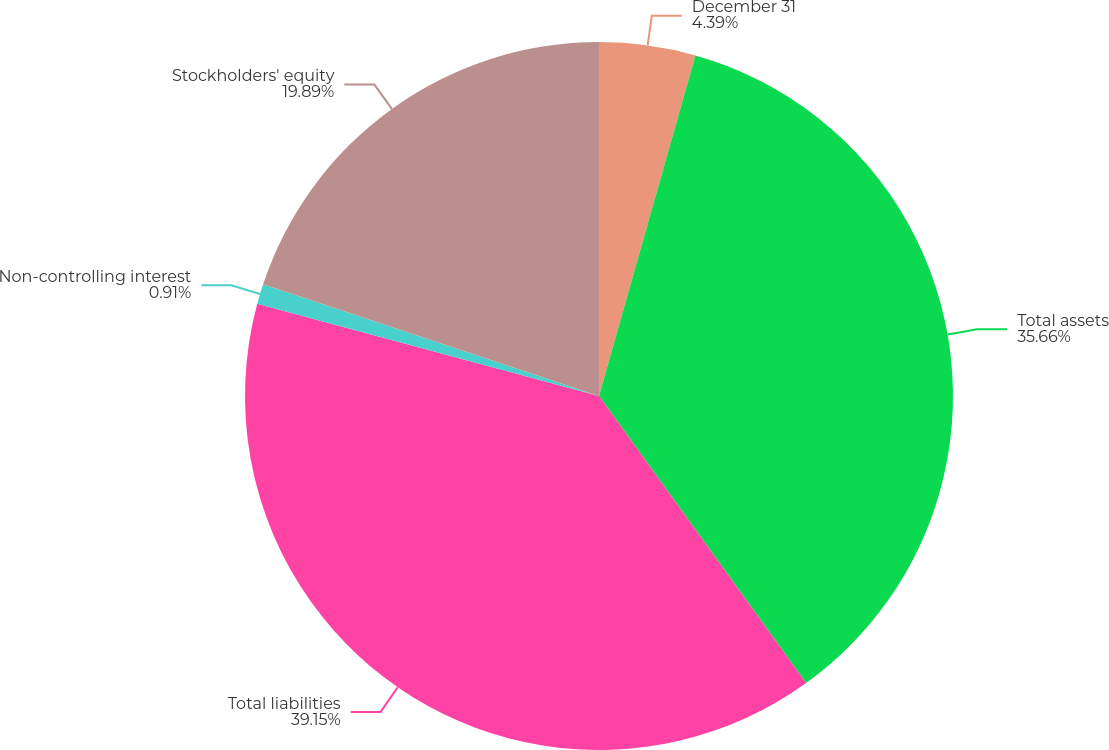Convert chart. <chart><loc_0><loc_0><loc_500><loc_500><pie_chart><fcel>December 31<fcel>Total assets<fcel>Total liabilities<fcel>Non-controlling interest<fcel>Stockholders' equity<nl><fcel>4.39%<fcel>35.66%<fcel>39.14%<fcel>0.91%<fcel>19.89%<nl></chart> 